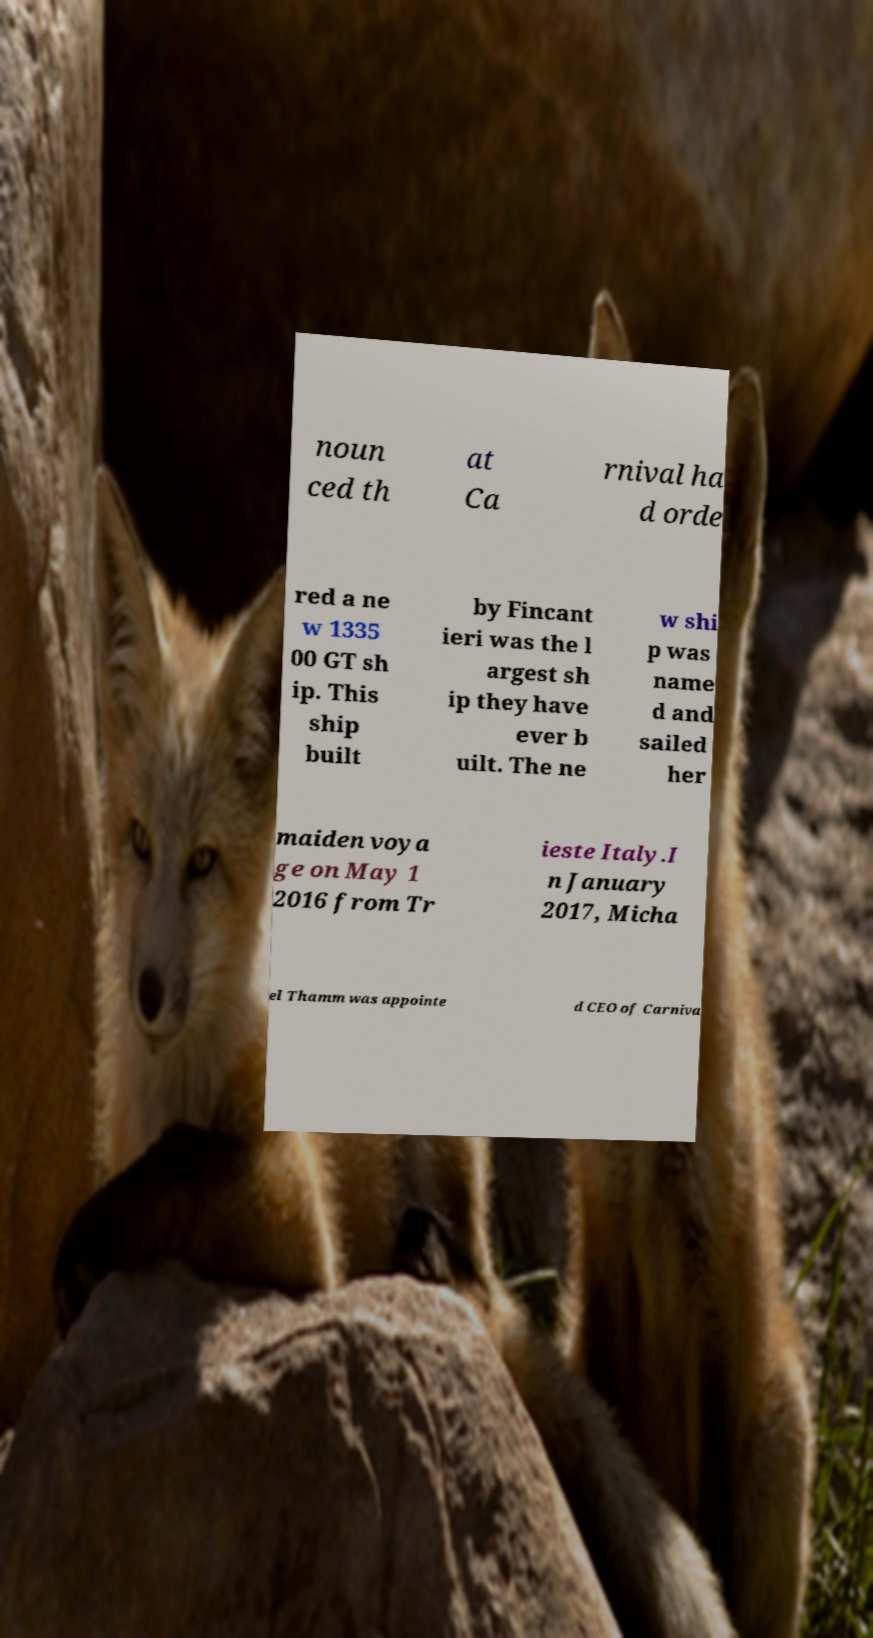I need the written content from this picture converted into text. Can you do that? noun ced th at Ca rnival ha d orde red a ne w 1335 00 GT sh ip. This ship built by Fincant ieri was the l argest sh ip they have ever b uilt. The ne w shi p was name d and sailed her maiden voya ge on May 1 2016 from Tr ieste Italy.I n January 2017, Micha el Thamm was appointe d CEO of Carniva 